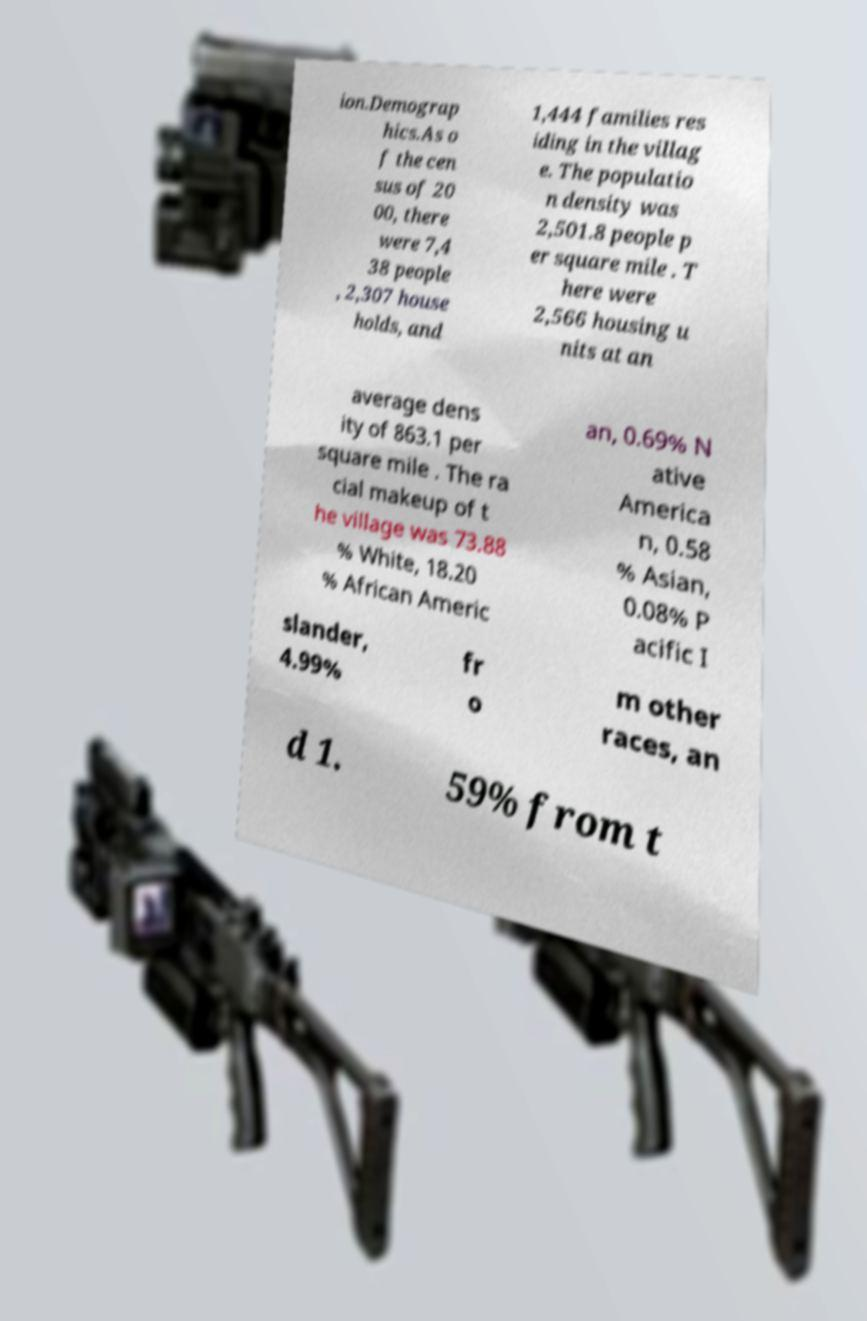Could you extract and type out the text from this image? ion.Demograp hics.As o f the cen sus of 20 00, there were 7,4 38 people , 2,307 house holds, and 1,444 families res iding in the villag e. The populatio n density was 2,501.8 people p er square mile . T here were 2,566 housing u nits at an average dens ity of 863.1 per square mile . The ra cial makeup of t he village was 73.88 % White, 18.20 % African Americ an, 0.69% N ative America n, 0.58 % Asian, 0.08% P acific I slander, 4.99% fr o m other races, an d 1. 59% from t 